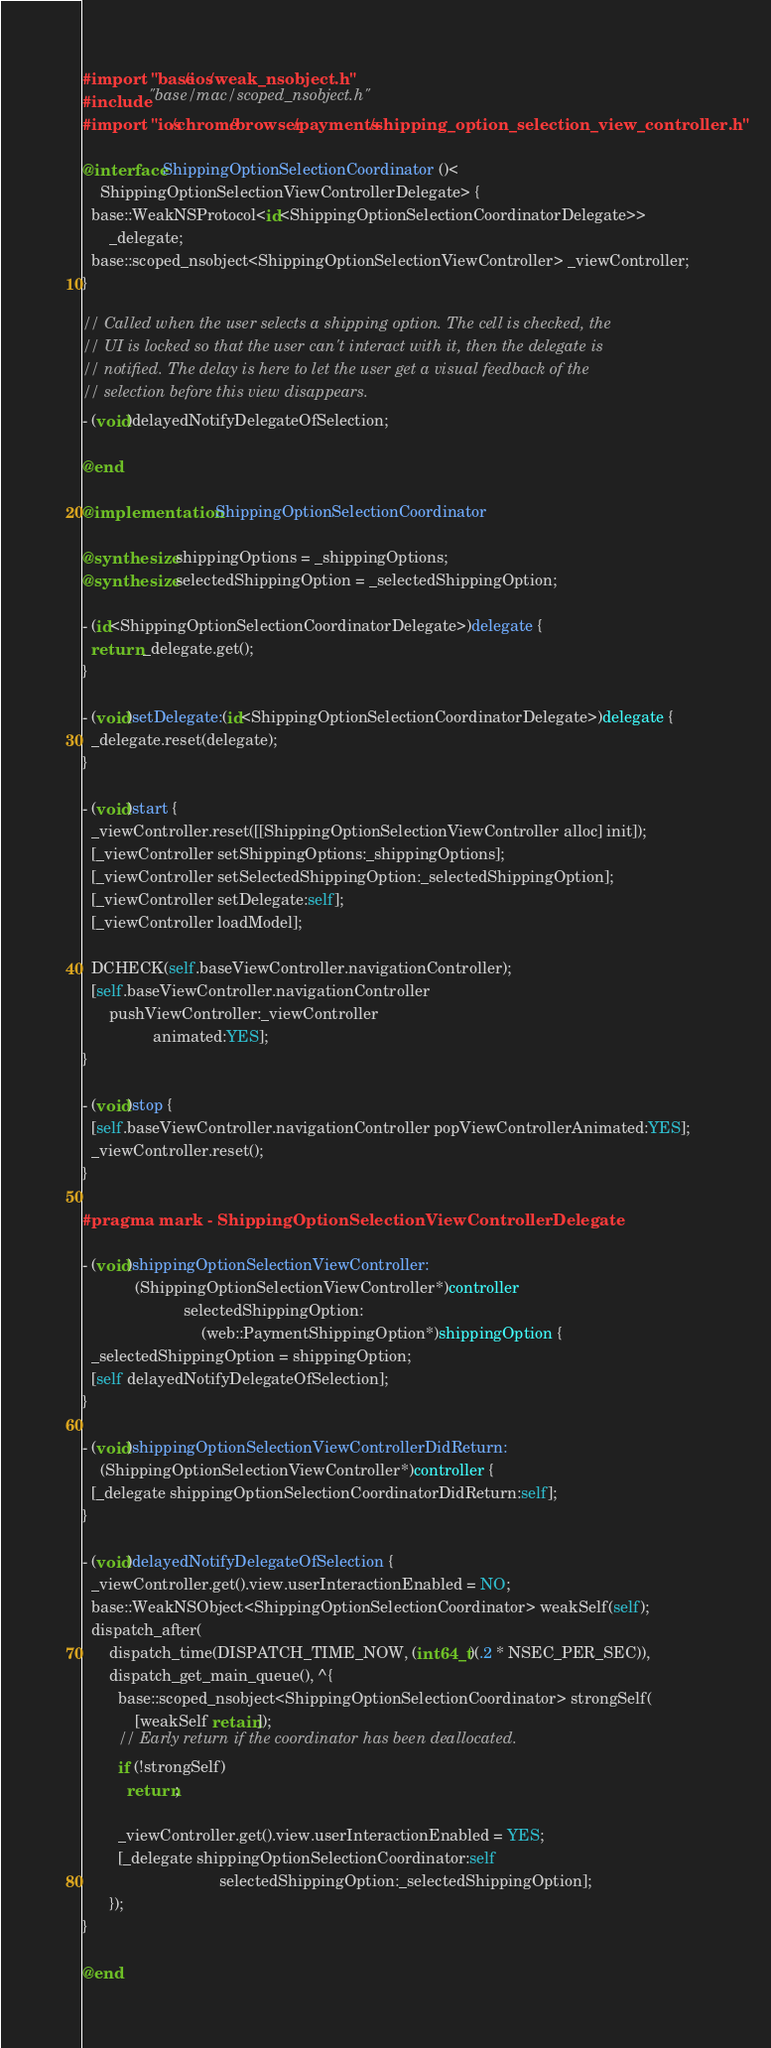<code> <loc_0><loc_0><loc_500><loc_500><_ObjectiveC_>#import "base/ios/weak_nsobject.h"
#include "base/mac/scoped_nsobject.h"
#import "ios/chrome/browser/payments/shipping_option_selection_view_controller.h"

@interface ShippingOptionSelectionCoordinator ()<
    ShippingOptionSelectionViewControllerDelegate> {
  base::WeakNSProtocol<id<ShippingOptionSelectionCoordinatorDelegate>>
      _delegate;
  base::scoped_nsobject<ShippingOptionSelectionViewController> _viewController;
}

// Called when the user selects a shipping option. The cell is checked, the
// UI is locked so that the user can't interact with it, then the delegate is
// notified. The delay is here to let the user get a visual feedback of the
// selection before this view disappears.
- (void)delayedNotifyDelegateOfSelection;

@end

@implementation ShippingOptionSelectionCoordinator

@synthesize shippingOptions = _shippingOptions;
@synthesize selectedShippingOption = _selectedShippingOption;

- (id<ShippingOptionSelectionCoordinatorDelegate>)delegate {
  return _delegate.get();
}

- (void)setDelegate:(id<ShippingOptionSelectionCoordinatorDelegate>)delegate {
  _delegate.reset(delegate);
}

- (void)start {
  _viewController.reset([[ShippingOptionSelectionViewController alloc] init]);
  [_viewController setShippingOptions:_shippingOptions];
  [_viewController setSelectedShippingOption:_selectedShippingOption];
  [_viewController setDelegate:self];
  [_viewController loadModel];

  DCHECK(self.baseViewController.navigationController);
  [self.baseViewController.navigationController
      pushViewController:_viewController
                animated:YES];
}

- (void)stop {
  [self.baseViewController.navigationController popViewControllerAnimated:YES];
  _viewController.reset();
}

#pragma mark - ShippingOptionSelectionViewControllerDelegate

- (void)shippingOptionSelectionViewController:
            (ShippingOptionSelectionViewController*)controller
                       selectedShippingOption:
                           (web::PaymentShippingOption*)shippingOption {
  _selectedShippingOption = shippingOption;
  [self delayedNotifyDelegateOfSelection];
}

- (void)shippingOptionSelectionViewControllerDidReturn:
    (ShippingOptionSelectionViewController*)controller {
  [_delegate shippingOptionSelectionCoordinatorDidReturn:self];
}

- (void)delayedNotifyDelegateOfSelection {
  _viewController.get().view.userInteractionEnabled = NO;
  base::WeakNSObject<ShippingOptionSelectionCoordinator> weakSelf(self);
  dispatch_after(
      dispatch_time(DISPATCH_TIME_NOW, (int64_t)(.2 * NSEC_PER_SEC)),
      dispatch_get_main_queue(), ^{
        base::scoped_nsobject<ShippingOptionSelectionCoordinator> strongSelf(
            [weakSelf retain]);
        // Early return if the coordinator has been deallocated.
        if (!strongSelf)
          return;

        _viewController.get().view.userInteractionEnabled = YES;
        [_delegate shippingOptionSelectionCoordinator:self
                               selectedShippingOption:_selectedShippingOption];
      });
}

@end
</code> 